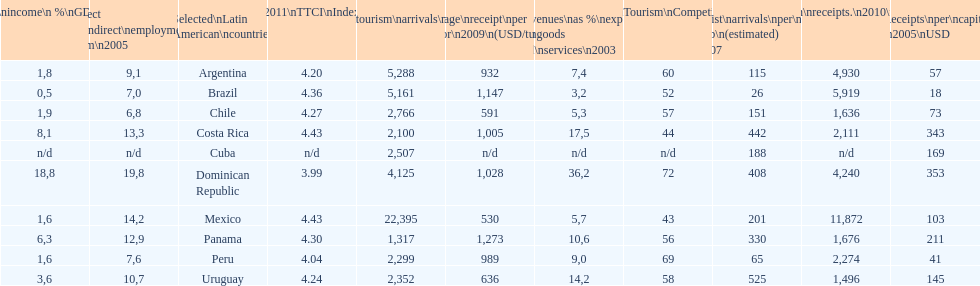What country makes the most tourist income? Dominican Republic. 